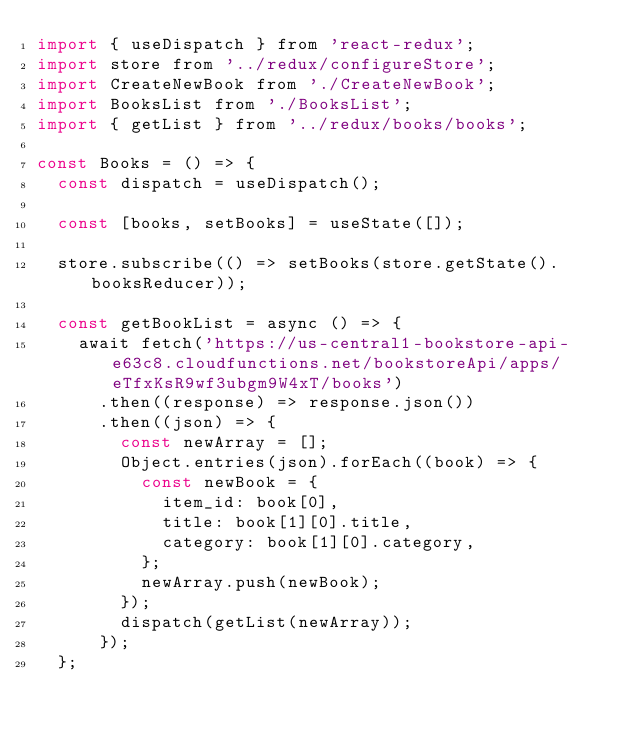<code> <loc_0><loc_0><loc_500><loc_500><_JavaScript_>import { useDispatch } from 'react-redux';
import store from '../redux/configureStore';
import CreateNewBook from './CreateNewBook';
import BooksList from './BooksList';
import { getList } from '../redux/books/books';

const Books = () => {
  const dispatch = useDispatch();

  const [books, setBooks] = useState([]);

  store.subscribe(() => setBooks(store.getState().booksReducer));

  const getBookList = async () => {
    await fetch('https://us-central1-bookstore-api-e63c8.cloudfunctions.net/bookstoreApi/apps/eTfxKsR9wf3ubgm9W4xT/books')
      .then((response) => response.json())
      .then((json) => {
        const newArray = [];
        Object.entries(json).forEach((book) => {
          const newBook = {
            item_id: book[0],
            title: book[1][0].title,
            category: book[1][0].category,
          };
          newArray.push(newBook);
        });
        dispatch(getList(newArray));
      });
  };
</code> 